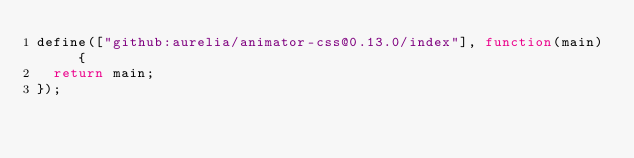<code> <loc_0><loc_0><loc_500><loc_500><_JavaScript_>define(["github:aurelia/animator-css@0.13.0/index"], function(main) {
  return main;
});</code> 